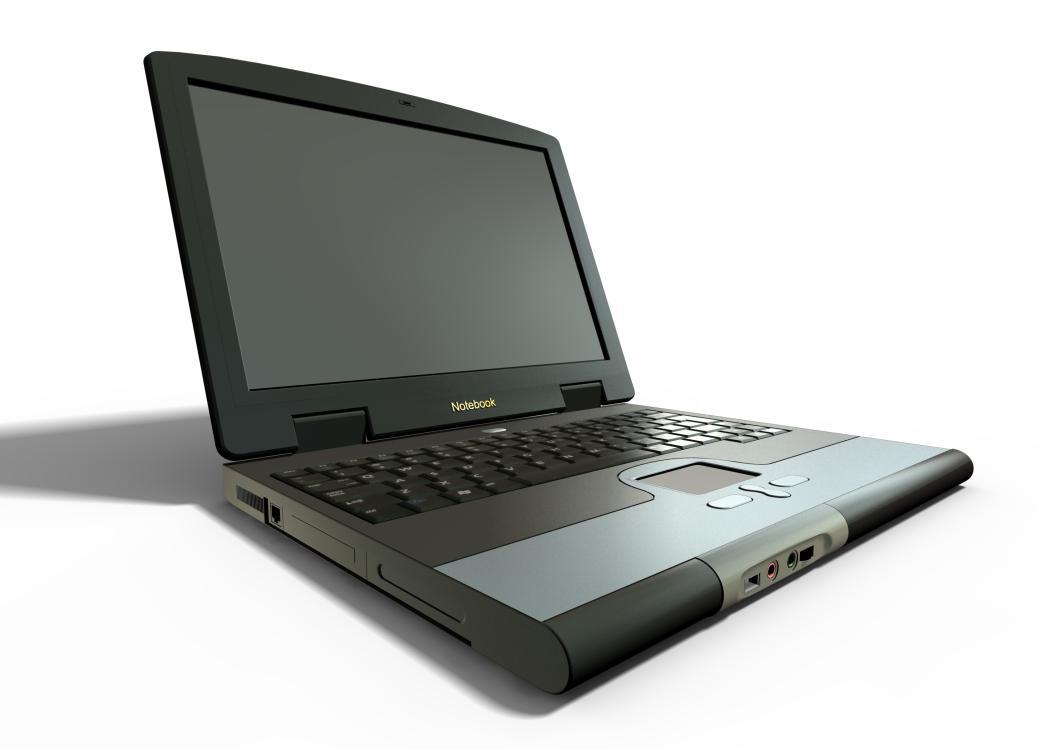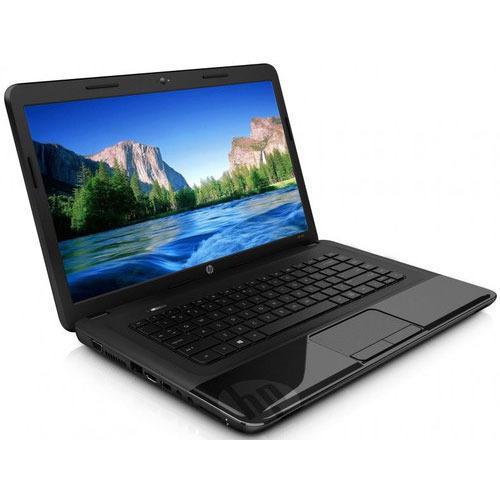The first image is the image on the left, the second image is the image on the right. Given the left and right images, does the statement "One of the laptops has a blank screen." hold true? Answer yes or no. Yes. The first image is the image on the left, the second image is the image on the right. Examine the images to the left and right. Is the description "Each image contains exactly one open laptop, and no laptop screen is disconnected from the base." accurate? Answer yes or no. Yes. 